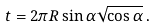<formula> <loc_0><loc_0><loc_500><loc_500>t = 2 \pi R \sin \alpha \sqrt { \cos \alpha } \, .</formula> 